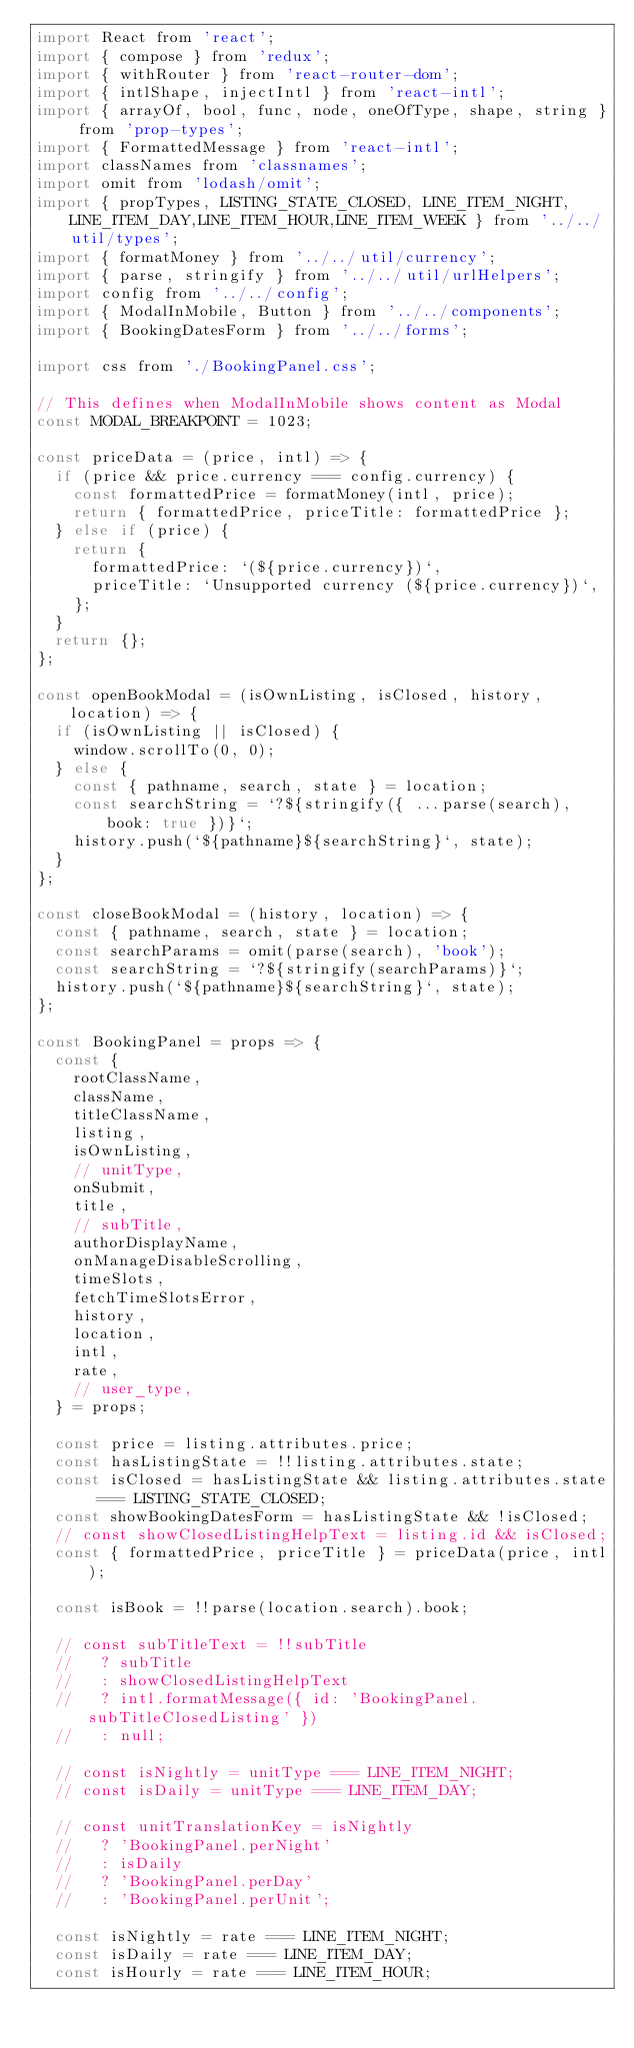<code> <loc_0><loc_0><loc_500><loc_500><_JavaScript_>import React from 'react';
import { compose } from 'redux';
import { withRouter } from 'react-router-dom';
import { intlShape, injectIntl } from 'react-intl';
import { arrayOf, bool, func, node, oneOfType, shape, string } from 'prop-types';
import { FormattedMessage } from 'react-intl';
import classNames from 'classnames';
import omit from 'lodash/omit';
import { propTypes, LISTING_STATE_CLOSED, LINE_ITEM_NIGHT, LINE_ITEM_DAY,LINE_ITEM_HOUR,LINE_ITEM_WEEK } from '../../util/types';
import { formatMoney } from '../../util/currency';
import { parse, stringify } from '../../util/urlHelpers';
import config from '../../config';
import { ModalInMobile, Button } from '../../components';
import { BookingDatesForm } from '../../forms';

import css from './BookingPanel.css';

// This defines when ModalInMobile shows content as Modal
const MODAL_BREAKPOINT = 1023;

const priceData = (price, intl) => {
  if (price && price.currency === config.currency) {
    const formattedPrice = formatMoney(intl, price);
    return { formattedPrice, priceTitle: formattedPrice };
  } else if (price) {
    return {
      formattedPrice: `(${price.currency})`,
      priceTitle: `Unsupported currency (${price.currency})`,
    };
  }
  return {};
};

const openBookModal = (isOwnListing, isClosed, history, location) => {
  if (isOwnListing || isClosed) {
    window.scrollTo(0, 0);
  } else {
    const { pathname, search, state } = location;
    const searchString = `?${stringify({ ...parse(search), book: true })}`;
    history.push(`${pathname}${searchString}`, state);
  }
};

const closeBookModal = (history, location) => {
  const { pathname, search, state } = location;
  const searchParams = omit(parse(search), 'book');
  const searchString = `?${stringify(searchParams)}`;
  history.push(`${pathname}${searchString}`, state);
};

const BookingPanel = props => {
  const {
    rootClassName,
    className,
    titleClassName,
    listing,
    isOwnListing,
    // unitType,
    onSubmit,
    title,
    // subTitle,
    authorDisplayName,
    onManageDisableScrolling,
    timeSlots,
    fetchTimeSlotsError,
    history,
    location,
    intl,
    rate,
    // user_type,
  } = props;

  const price = listing.attributes.price;
  const hasListingState = !!listing.attributes.state;
  const isClosed = hasListingState && listing.attributes.state === LISTING_STATE_CLOSED;
  const showBookingDatesForm = hasListingState && !isClosed;
  // const showClosedListingHelpText = listing.id && isClosed;
  const { formattedPrice, priceTitle } = priceData(price, intl);
  
  const isBook = !!parse(location.search).book;

  // const subTitleText = !!subTitle
  //   ? subTitle
  //   : showClosedListingHelpText
  //   ? intl.formatMessage({ id: 'BookingPanel.subTitleClosedListing' })
  //   : null;

  // const isNightly = unitType === LINE_ITEM_NIGHT;
  // const isDaily = unitType === LINE_ITEM_DAY;

  // const unitTranslationKey = isNightly
  //   ? 'BookingPanel.perNight'
  //   : isDaily
  //   ? 'BookingPanel.perDay'
  //   : 'BookingPanel.perUnit';
    
  const isNightly = rate === LINE_ITEM_NIGHT;
  const isDaily = rate === LINE_ITEM_DAY;
  const isHourly = rate === LINE_ITEM_HOUR;</code> 